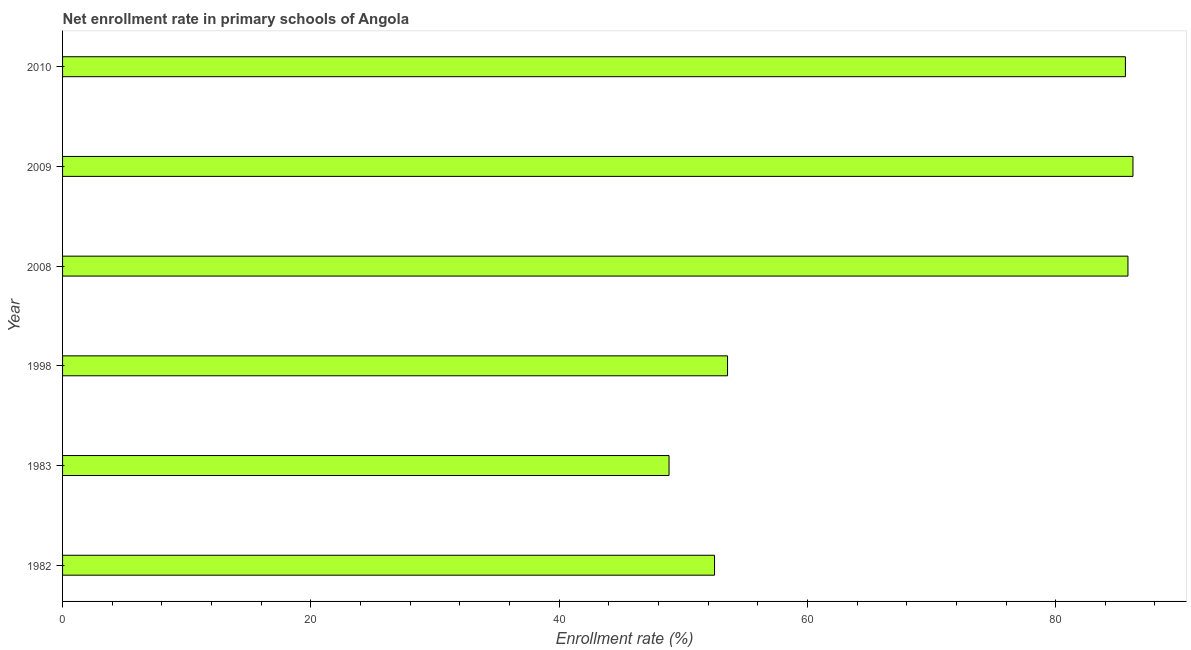What is the title of the graph?
Keep it short and to the point. Net enrollment rate in primary schools of Angola. What is the label or title of the X-axis?
Keep it short and to the point. Enrollment rate (%). What is the net enrollment rate in primary schools in 1998?
Offer a very short reply. 53.57. Across all years, what is the maximum net enrollment rate in primary schools?
Provide a short and direct response. 86.23. Across all years, what is the minimum net enrollment rate in primary schools?
Ensure brevity in your answer.  48.86. What is the sum of the net enrollment rate in primary schools?
Provide a succinct answer. 412.62. What is the difference between the net enrollment rate in primary schools in 1982 and 2008?
Give a very brief answer. -33.3. What is the average net enrollment rate in primary schools per year?
Your answer should be very brief. 68.77. What is the median net enrollment rate in primary schools?
Make the answer very short. 69.59. What is the ratio of the net enrollment rate in primary schools in 1982 to that in 2008?
Provide a short and direct response. 0.61. Is the net enrollment rate in primary schools in 2008 less than that in 2010?
Ensure brevity in your answer.  No. Is the difference between the net enrollment rate in primary schools in 1998 and 2009 greater than the difference between any two years?
Provide a succinct answer. No. What is the difference between the highest and the second highest net enrollment rate in primary schools?
Your response must be concise. 0.4. What is the difference between the highest and the lowest net enrollment rate in primary schools?
Ensure brevity in your answer.  37.37. In how many years, is the net enrollment rate in primary schools greater than the average net enrollment rate in primary schools taken over all years?
Offer a terse response. 3. Are all the bars in the graph horizontal?
Offer a terse response. Yes. Are the values on the major ticks of X-axis written in scientific E-notation?
Your answer should be compact. No. What is the Enrollment rate (%) in 1982?
Keep it short and to the point. 52.52. What is the Enrollment rate (%) in 1983?
Keep it short and to the point. 48.86. What is the Enrollment rate (%) in 1998?
Your answer should be compact. 53.57. What is the Enrollment rate (%) of 2008?
Provide a short and direct response. 85.82. What is the Enrollment rate (%) in 2009?
Your answer should be very brief. 86.23. What is the Enrollment rate (%) of 2010?
Ensure brevity in your answer.  85.62. What is the difference between the Enrollment rate (%) in 1982 and 1983?
Offer a very short reply. 3.67. What is the difference between the Enrollment rate (%) in 1982 and 1998?
Keep it short and to the point. -1.05. What is the difference between the Enrollment rate (%) in 1982 and 2008?
Give a very brief answer. -33.3. What is the difference between the Enrollment rate (%) in 1982 and 2009?
Keep it short and to the point. -33.71. What is the difference between the Enrollment rate (%) in 1982 and 2010?
Provide a short and direct response. -33.1. What is the difference between the Enrollment rate (%) in 1983 and 1998?
Provide a succinct answer. -4.71. What is the difference between the Enrollment rate (%) in 1983 and 2008?
Your response must be concise. -36.97. What is the difference between the Enrollment rate (%) in 1983 and 2009?
Your answer should be very brief. -37.37. What is the difference between the Enrollment rate (%) in 1983 and 2010?
Your answer should be very brief. -36.76. What is the difference between the Enrollment rate (%) in 1998 and 2008?
Give a very brief answer. -32.26. What is the difference between the Enrollment rate (%) in 1998 and 2009?
Provide a short and direct response. -32.66. What is the difference between the Enrollment rate (%) in 1998 and 2010?
Offer a very short reply. -32.05. What is the difference between the Enrollment rate (%) in 2008 and 2009?
Keep it short and to the point. -0.4. What is the difference between the Enrollment rate (%) in 2008 and 2010?
Your answer should be very brief. 0.2. What is the difference between the Enrollment rate (%) in 2009 and 2010?
Offer a terse response. 0.61. What is the ratio of the Enrollment rate (%) in 1982 to that in 1983?
Ensure brevity in your answer.  1.07. What is the ratio of the Enrollment rate (%) in 1982 to that in 1998?
Provide a short and direct response. 0.98. What is the ratio of the Enrollment rate (%) in 1982 to that in 2008?
Provide a short and direct response. 0.61. What is the ratio of the Enrollment rate (%) in 1982 to that in 2009?
Make the answer very short. 0.61. What is the ratio of the Enrollment rate (%) in 1982 to that in 2010?
Provide a succinct answer. 0.61. What is the ratio of the Enrollment rate (%) in 1983 to that in 1998?
Your answer should be compact. 0.91. What is the ratio of the Enrollment rate (%) in 1983 to that in 2008?
Ensure brevity in your answer.  0.57. What is the ratio of the Enrollment rate (%) in 1983 to that in 2009?
Ensure brevity in your answer.  0.57. What is the ratio of the Enrollment rate (%) in 1983 to that in 2010?
Ensure brevity in your answer.  0.57. What is the ratio of the Enrollment rate (%) in 1998 to that in 2008?
Give a very brief answer. 0.62. What is the ratio of the Enrollment rate (%) in 1998 to that in 2009?
Give a very brief answer. 0.62. What is the ratio of the Enrollment rate (%) in 1998 to that in 2010?
Your answer should be very brief. 0.63. What is the ratio of the Enrollment rate (%) in 2008 to that in 2010?
Your answer should be very brief. 1. 